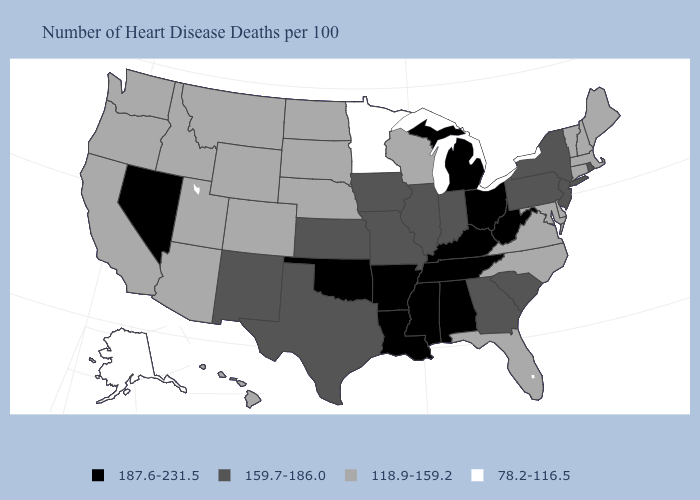Name the states that have a value in the range 118.9-159.2?
Quick response, please. Arizona, California, Colorado, Connecticut, Delaware, Florida, Hawaii, Idaho, Maine, Maryland, Massachusetts, Montana, Nebraska, New Hampshire, North Carolina, North Dakota, Oregon, South Dakota, Utah, Vermont, Virginia, Washington, Wisconsin, Wyoming. Among the states that border Montana , which have the highest value?
Quick response, please. Idaho, North Dakota, South Dakota, Wyoming. Name the states that have a value in the range 159.7-186.0?
Short answer required. Georgia, Illinois, Indiana, Iowa, Kansas, Missouri, New Jersey, New Mexico, New York, Pennsylvania, Rhode Island, South Carolina, Texas. Name the states that have a value in the range 118.9-159.2?
Keep it brief. Arizona, California, Colorado, Connecticut, Delaware, Florida, Hawaii, Idaho, Maine, Maryland, Massachusetts, Montana, Nebraska, New Hampshire, North Carolina, North Dakota, Oregon, South Dakota, Utah, Vermont, Virginia, Washington, Wisconsin, Wyoming. What is the value of Iowa?
Be succinct. 159.7-186.0. What is the lowest value in states that border Delaware?
Write a very short answer. 118.9-159.2. Does Maryland have the same value as Idaho?
Answer briefly. Yes. Which states have the lowest value in the USA?
Concise answer only. Alaska, Minnesota. Among the states that border Pennsylvania , which have the highest value?
Write a very short answer. Ohio, West Virginia. Name the states that have a value in the range 78.2-116.5?
Quick response, please. Alaska, Minnesota. What is the value of Alabama?
Be succinct. 187.6-231.5. Name the states that have a value in the range 187.6-231.5?
Quick response, please. Alabama, Arkansas, Kentucky, Louisiana, Michigan, Mississippi, Nevada, Ohio, Oklahoma, Tennessee, West Virginia. Name the states that have a value in the range 118.9-159.2?
Keep it brief. Arizona, California, Colorado, Connecticut, Delaware, Florida, Hawaii, Idaho, Maine, Maryland, Massachusetts, Montana, Nebraska, New Hampshire, North Carolina, North Dakota, Oregon, South Dakota, Utah, Vermont, Virginia, Washington, Wisconsin, Wyoming. What is the value of Wyoming?
Keep it brief. 118.9-159.2. Among the states that border New Jersey , does Pennsylvania have the lowest value?
Write a very short answer. No. 